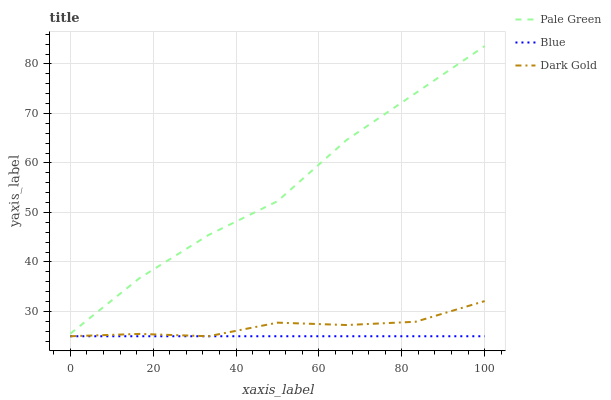Does Blue have the minimum area under the curve?
Answer yes or no. Yes. Does Pale Green have the maximum area under the curve?
Answer yes or no. Yes. Does Dark Gold have the minimum area under the curve?
Answer yes or no. No. Does Dark Gold have the maximum area under the curve?
Answer yes or no. No. Is Blue the smoothest?
Answer yes or no. Yes. Is Pale Green the roughest?
Answer yes or no. Yes. Is Dark Gold the smoothest?
Answer yes or no. No. Is Dark Gold the roughest?
Answer yes or no. No. Does Pale Green have the lowest value?
Answer yes or no. No. Does Pale Green have the highest value?
Answer yes or no. Yes. Does Dark Gold have the highest value?
Answer yes or no. No. Is Dark Gold less than Pale Green?
Answer yes or no. Yes. Is Pale Green greater than Blue?
Answer yes or no. Yes. Does Dark Gold intersect Blue?
Answer yes or no. Yes. Is Dark Gold less than Blue?
Answer yes or no. No. Is Dark Gold greater than Blue?
Answer yes or no. No. Does Dark Gold intersect Pale Green?
Answer yes or no. No. 